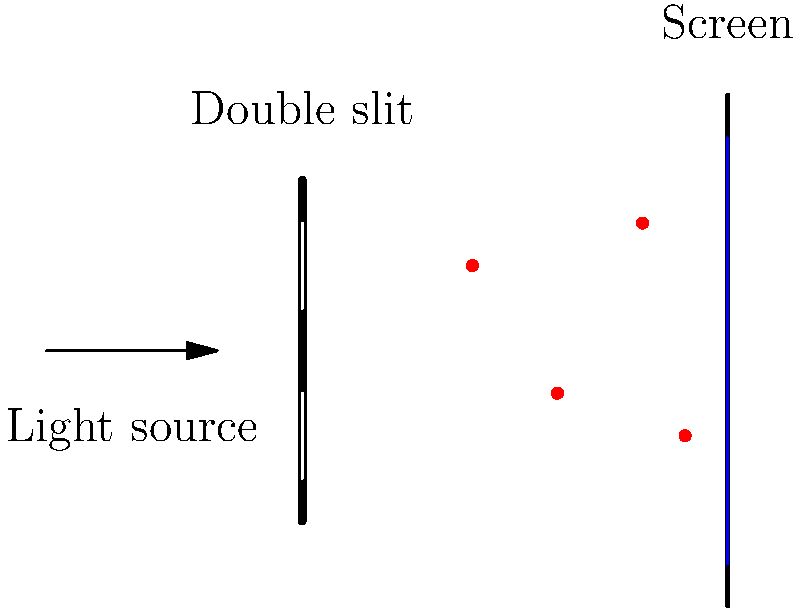In the double-slit experiment shown above, light exhibits both wave-like and particle-like behavior. How does this experiment demonstrate the concept of wave-particle duality, and what spiritual insights might we draw from this phenomenon? 1. Wave behavior: The light passing through the double slits creates an interference pattern on the screen, which is characteristic of waves. This is shown by the blue curve on the screen in the diagram.

2. Particle behavior: Individual photons (represented by red dots) are detected at specific points on the screen, demonstrating particle-like properties.

3. Wave-particle duality: The experiment shows that light behaves as both a wave (interference pattern) and a particle (individual photon detections) simultaneously.

4. Quantum superposition: Before measurement, each photon exists in a superposition of states, passing through both slits simultaneously.

5. Observation effect: The act of measuring or observing which slit a photon passes through disrupts the interference pattern, collapsing the wave function.

6. Spiritual insight: This duality can be seen as a metaphor for the complex nature of reality and spirituality. Just as light can be both a wave and a particle, spiritual truths may have multiple, seemingly contradictory aspects that are simultaneously true.

7. Interconnectedness: The wave nature of light suggests interconnectedness, as the behavior of one photon affects the entire pattern. This parallels spiritual concepts of unity and interdependence found in many traditions.

8. Mystery and humility: The counterintuitive nature of quantum phenomena reminds us that reality can be more complex than our everyday perceptions, encouraging humility and openness in our spiritual explorations.

9. Observational influence: The impact of observation on quantum systems can be related to the idea that our consciousness and intentions may influence spiritual experiences and outcomes.
Answer: Wave-particle duality: light exhibits both wave (interference pattern) and particle (individual photon detection) properties, revealing the complex nature of reality and encouraging spiritual reflection on interconnectedness, mystery, and the role of consciousness in shaping our experiences. 